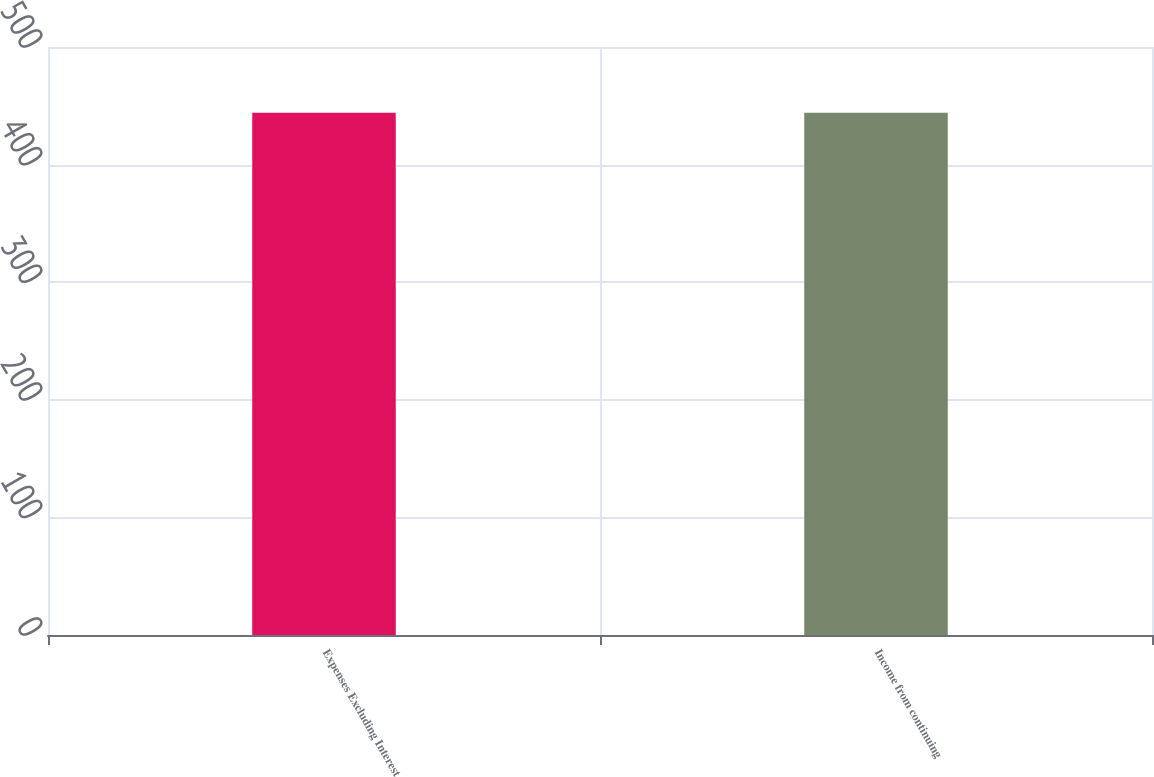<chart> <loc_0><loc_0><loc_500><loc_500><bar_chart><fcel>Expenses Excluding Interest<fcel>Income from continuing<nl><fcel>444<fcel>444.1<nl></chart> 